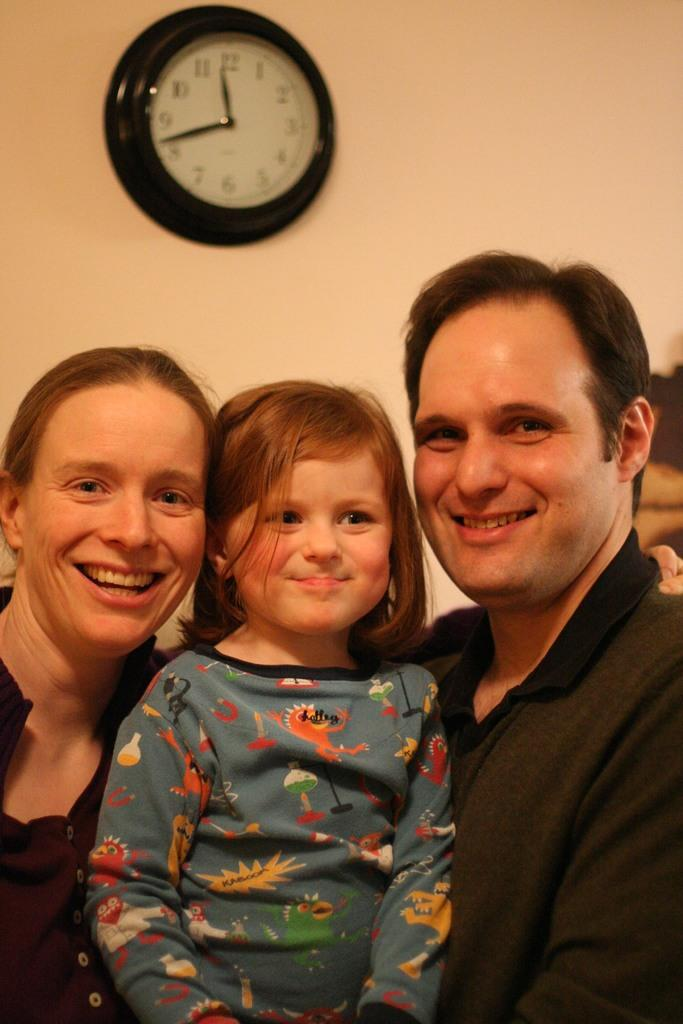Provide a one-sentence caption for the provided image. Two adults with a child between them, wearing a shirt with a shirt with a graphic of KABOOM on a jagged yellow shape on it. 